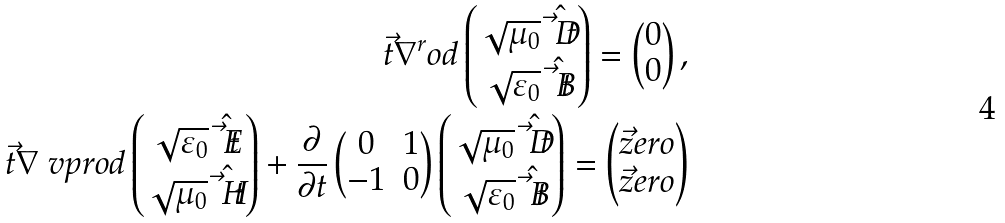<formula> <loc_0><loc_0><loc_500><loc_500>\vec { t } { \nabla } ^ { r } o d \begin{pmatrix} \sqrt { \mu _ { 0 } } \hat { \vec { t } { D } } \\ \sqrt { \varepsilon _ { 0 } } \hat { \vec { t } { B } } \end{pmatrix} = \begin{pmatrix} 0 \\ 0 \end{pmatrix} , \\ \vec { t } { \nabla } \ v p r o d \begin{pmatrix} \sqrt { \varepsilon _ { 0 } } \hat { \vec { t } { E } } \\ \sqrt { \mu _ { 0 } } \hat { \vec { t } { H } } \end{pmatrix} + \frac { \partial } { \partial t } \begin{pmatrix} 0 & 1 \\ - 1 & 0 \end{pmatrix} \begin{pmatrix} \sqrt { \mu _ { 0 } } \hat { \vec { t } { D } } \\ \sqrt { \varepsilon _ { 0 } } \hat { \vec { t } { B } } \end{pmatrix} = \begin{pmatrix} \vec { z } e r o \\ \vec { z } e r o \end{pmatrix}</formula> 